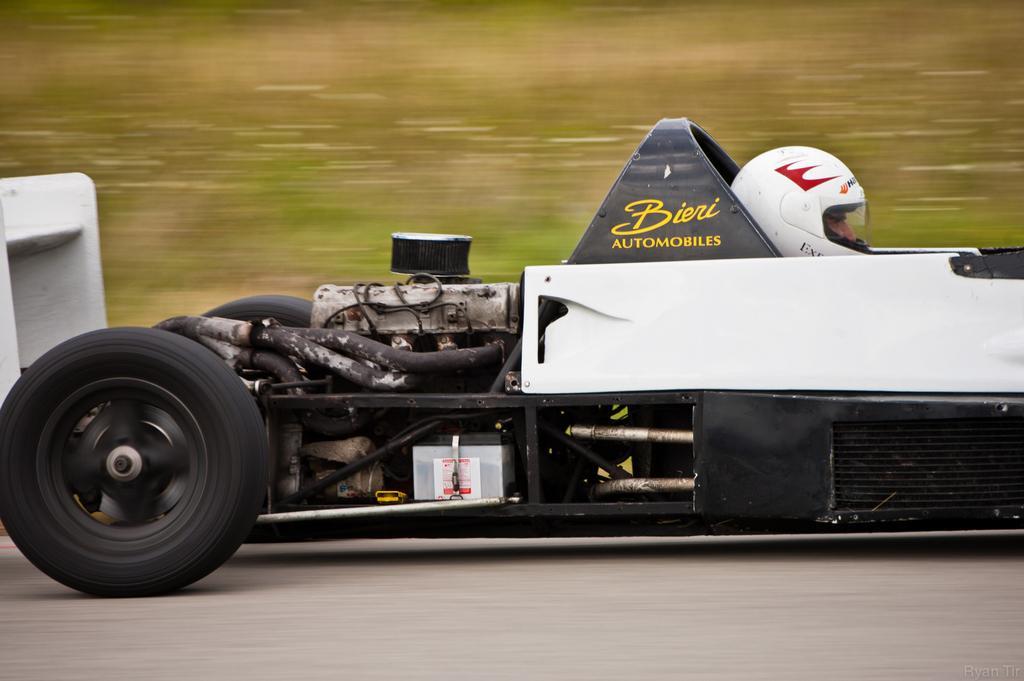How would you summarize this image in a sentence or two? In this image we can see a car on the road and a person sitting in the car and a blurry background. 